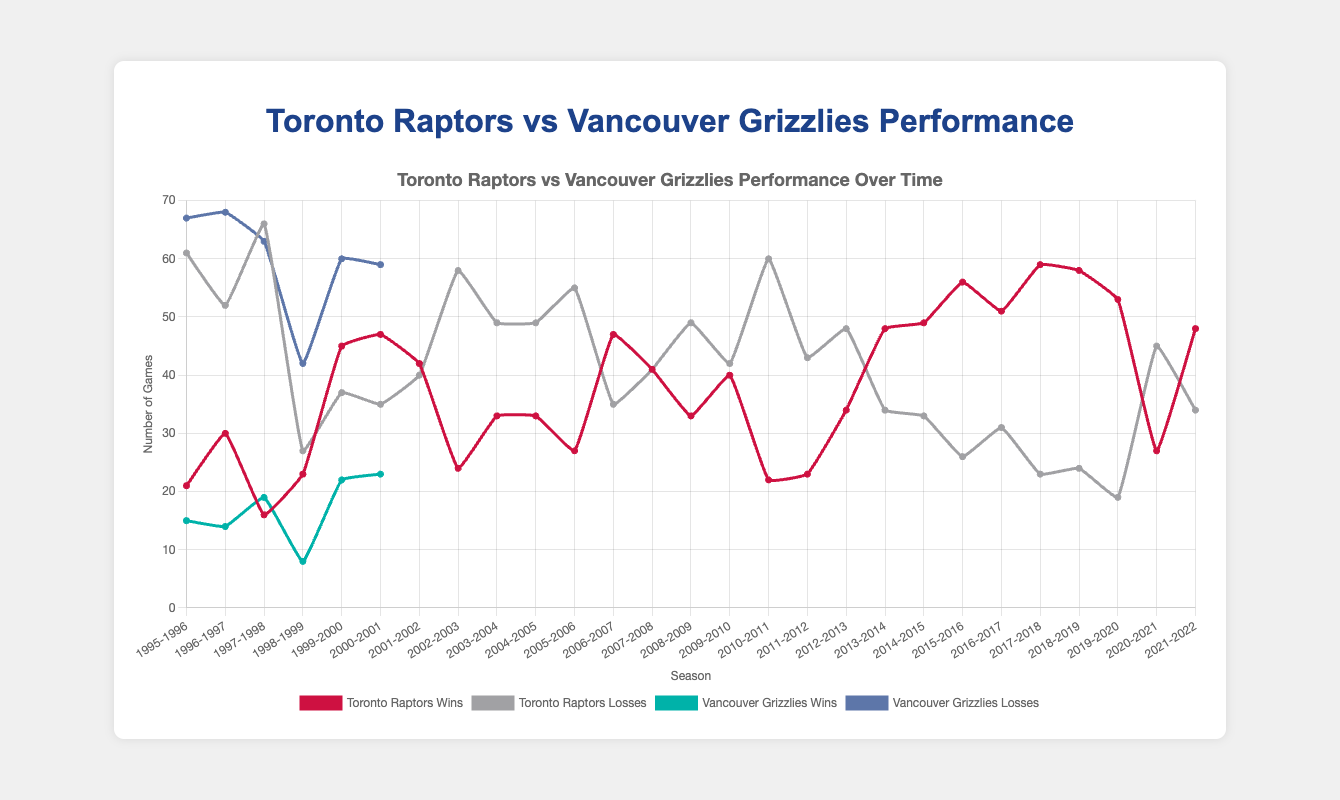Which team had the highest number of wins in a single season? Look at the 'Toronto Raptors Wins' and 'Vancouver Grizzlies Wins' lines and identify the maximum value. The highest win for the Raptors is in the 2017-2018 season with 59 wins, while for the Grizzlies, the maximum is 23 wins in the 2000-2001 season.
Answer: Toronto Raptors In which season did the Toronto Raptors first achieve more wins than losses? Compare the Toronto Raptors' wins and losses for each season until you find a season where wins exceed losses. This happens in the 1999-2000 season where the Raptors had 45 wins and 37 losses.
Answer: 1999-2000 What is the overall trend for the Vancouver Grizzlies' performance from 1995 to 2001? Examine the 'Vancouver Grizzlies Wins' line over the seasons from 1995-1996 to 2000-2001. Notice that the win counts remain consistently low and show only slight improvement from 15 wins in 1995-1996 to 23 wins in 2000-2001.
Answer: Consistently low performance with slight improvement How does the number of wins for the Raptors in the 2018-2019 season compare to the number of wins in the 1995-1996 season? Identify the win counts for the Toronto Raptors in the 2018-2019 and 1995-1996 seasons from the chart. In 1995-1996, they had 21 wins, and in 2018-2019, they had 58 wins. Comparing them shows a significant increase in wins.
Answer: 2018-2019 had significantly more wins than 1995-1996 What was the best season for the Toronto Raptors in terms of wins? Look at the peak point of the 'Toronto Raptors Wins' line across all seasons to determine their best season. The highest point is in the 2017-2018 season with 59 wins.
Answer: 2017-2018 During which seasons did the Vancouver Grizzlies have fewer than 20 wins? Identify the seasons where the 'Vancouver Grizzlies Wins' line falls below 20. These seasons are 1995-1996, 1996-1997, 1997-1998, and 1998-1999.
Answer: 1995-1996, 1996-1997, 1997-1998, 1998-1999 Which team has the best peak performance, and in which season was it achieved? Compare the maximum win counts for both teams. The Raptors' peak is 59 wins in 2017-2018, while the Grizzlies' peak is 23 wins in 2000-2001. The highest peak is by the Raptors in 2017-2018.
Answer: Toronto Raptors in 2017-2018 What's the average number of wins for the Raptors over the seasons 1995-2022? Calculate the sum of all wins for the Raptors from 1995-2022 and divide by the number of seasons. Sum (1263 wins) / 27 seasons gives approximately 46.78 wins.
Answer: 46.78 Did the Raptors or Grizzlies have a better overall winning trend from their inception until 2001? Examine the overall patterns of 'Toronto Raptors Wins' and 'Vancouver Grizzlies Wins'. Raptors show a gradual improvement and better performance from 21 wins in 1995-1996 to 47 wins in 2000-2001, while the Grizzlies remain consistently low with only slight improvement.
Answer: Toronto Raptors 